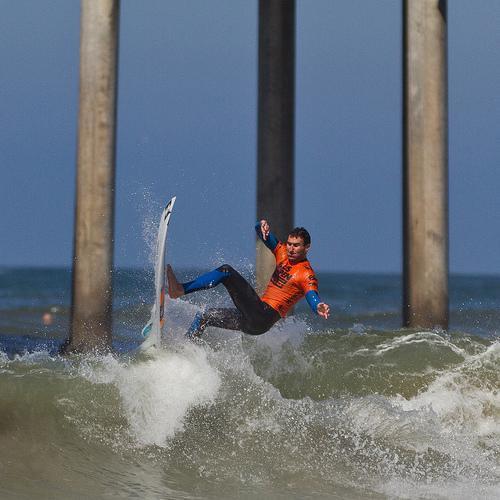How many people in the picture?
Give a very brief answer. 1. How many pillars in the background?
Give a very brief answer. 3. 